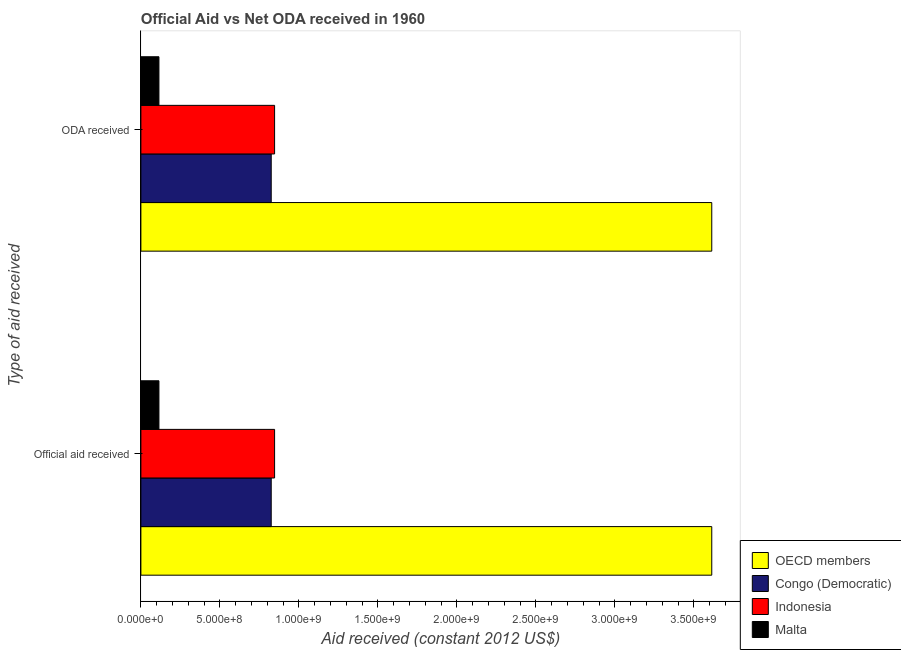How many different coloured bars are there?
Provide a short and direct response. 4. How many groups of bars are there?
Provide a short and direct response. 2. How many bars are there on the 2nd tick from the bottom?
Your answer should be compact. 4. What is the label of the 1st group of bars from the top?
Ensure brevity in your answer.  ODA received. What is the oda received in Congo (Democratic)?
Keep it short and to the point. 8.25e+08. Across all countries, what is the maximum oda received?
Your response must be concise. 3.61e+09. Across all countries, what is the minimum oda received?
Make the answer very short. 1.14e+08. In which country was the oda received maximum?
Offer a terse response. OECD members. In which country was the official aid received minimum?
Your answer should be very brief. Malta. What is the total oda received in the graph?
Offer a terse response. 5.40e+09. What is the difference between the oda received in OECD members and that in Malta?
Offer a terse response. 3.50e+09. What is the difference between the oda received in Congo (Democratic) and the official aid received in OECD members?
Provide a short and direct response. -2.79e+09. What is the average oda received per country?
Offer a very short reply. 1.35e+09. In how many countries, is the oda received greater than 2900000000 US$?
Offer a very short reply. 1. What is the ratio of the oda received in OECD members to that in Indonesia?
Ensure brevity in your answer.  4.27. What does the 2nd bar from the bottom in Official aid received represents?
Provide a succinct answer. Congo (Democratic). What is the difference between two consecutive major ticks on the X-axis?
Offer a very short reply. 5.00e+08. Are the values on the major ticks of X-axis written in scientific E-notation?
Provide a succinct answer. Yes. Does the graph contain any zero values?
Your response must be concise. No. Where does the legend appear in the graph?
Offer a very short reply. Bottom right. How many legend labels are there?
Your answer should be compact. 4. How are the legend labels stacked?
Keep it short and to the point. Vertical. What is the title of the graph?
Keep it short and to the point. Official Aid vs Net ODA received in 1960 . What is the label or title of the X-axis?
Ensure brevity in your answer.  Aid received (constant 2012 US$). What is the label or title of the Y-axis?
Ensure brevity in your answer.  Type of aid received. What is the Aid received (constant 2012 US$) of OECD members in Official aid received?
Give a very brief answer. 3.61e+09. What is the Aid received (constant 2012 US$) in Congo (Democratic) in Official aid received?
Make the answer very short. 8.25e+08. What is the Aid received (constant 2012 US$) of Indonesia in Official aid received?
Give a very brief answer. 8.46e+08. What is the Aid received (constant 2012 US$) in Malta in Official aid received?
Your answer should be very brief. 1.14e+08. What is the Aid received (constant 2012 US$) in OECD members in ODA received?
Keep it short and to the point. 3.61e+09. What is the Aid received (constant 2012 US$) of Congo (Democratic) in ODA received?
Make the answer very short. 8.25e+08. What is the Aid received (constant 2012 US$) in Indonesia in ODA received?
Ensure brevity in your answer.  8.46e+08. What is the Aid received (constant 2012 US$) of Malta in ODA received?
Your answer should be compact. 1.14e+08. Across all Type of aid received, what is the maximum Aid received (constant 2012 US$) of OECD members?
Give a very brief answer. 3.61e+09. Across all Type of aid received, what is the maximum Aid received (constant 2012 US$) of Congo (Democratic)?
Ensure brevity in your answer.  8.25e+08. Across all Type of aid received, what is the maximum Aid received (constant 2012 US$) in Indonesia?
Offer a very short reply. 8.46e+08. Across all Type of aid received, what is the maximum Aid received (constant 2012 US$) of Malta?
Provide a succinct answer. 1.14e+08. Across all Type of aid received, what is the minimum Aid received (constant 2012 US$) in OECD members?
Give a very brief answer. 3.61e+09. Across all Type of aid received, what is the minimum Aid received (constant 2012 US$) of Congo (Democratic)?
Provide a short and direct response. 8.25e+08. Across all Type of aid received, what is the minimum Aid received (constant 2012 US$) of Indonesia?
Your response must be concise. 8.46e+08. Across all Type of aid received, what is the minimum Aid received (constant 2012 US$) of Malta?
Offer a very short reply. 1.14e+08. What is the total Aid received (constant 2012 US$) of OECD members in the graph?
Ensure brevity in your answer.  7.23e+09. What is the total Aid received (constant 2012 US$) of Congo (Democratic) in the graph?
Provide a succinct answer. 1.65e+09. What is the total Aid received (constant 2012 US$) in Indonesia in the graph?
Offer a terse response. 1.69e+09. What is the total Aid received (constant 2012 US$) in Malta in the graph?
Ensure brevity in your answer.  2.29e+08. What is the difference between the Aid received (constant 2012 US$) in OECD members in Official aid received and that in ODA received?
Ensure brevity in your answer.  0. What is the difference between the Aid received (constant 2012 US$) in OECD members in Official aid received and the Aid received (constant 2012 US$) in Congo (Democratic) in ODA received?
Your response must be concise. 2.79e+09. What is the difference between the Aid received (constant 2012 US$) of OECD members in Official aid received and the Aid received (constant 2012 US$) of Indonesia in ODA received?
Keep it short and to the point. 2.77e+09. What is the difference between the Aid received (constant 2012 US$) in OECD members in Official aid received and the Aid received (constant 2012 US$) in Malta in ODA received?
Keep it short and to the point. 3.50e+09. What is the difference between the Aid received (constant 2012 US$) in Congo (Democratic) in Official aid received and the Aid received (constant 2012 US$) in Indonesia in ODA received?
Give a very brief answer. -2.13e+07. What is the difference between the Aid received (constant 2012 US$) of Congo (Democratic) in Official aid received and the Aid received (constant 2012 US$) of Malta in ODA received?
Your answer should be very brief. 7.11e+08. What is the difference between the Aid received (constant 2012 US$) in Indonesia in Official aid received and the Aid received (constant 2012 US$) in Malta in ODA received?
Your answer should be compact. 7.32e+08. What is the average Aid received (constant 2012 US$) in OECD members per Type of aid received?
Provide a short and direct response. 3.61e+09. What is the average Aid received (constant 2012 US$) of Congo (Democratic) per Type of aid received?
Offer a terse response. 8.25e+08. What is the average Aid received (constant 2012 US$) of Indonesia per Type of aid received?
Provide a succinct answer. 8.46e+08. What is the average Aid received (constant 2012 US$) in Malta per Type of aid received?
Keep it short and to the point. 1.14e+08. What is the difference between the Aid received (constant 2012 US$) in OECD members and Aid received (constant 2012 US$) in Congo (Democratic) in Official aid received?
Your answer should be very brief. 2.79e+09. What is the difference between the Aid received (constant 2012 US$) of OECD members and Aid received (constant 2012 US$) of Indonesia in Official aid received?
Make the answer very short. 2.77e+09. What is the difference between the Aid received (constant 2012 US$) of OECD members and Aid received (constant 2012 US$) of Malta in Official aid received?
Provide a short and direct response. 3.50e+09. What is the difference between the Aid received (constant 2012 US$) in Congo (Democratic) and Aid received (constant 2012 US$) in Indonesia in Official aid received?
Ensure brevity in your answer.  -2.13e+07. What is the difference between the Aid received (constant 2012 US$) in Congo (Democratic) and Aid received (constant 2012 US$) in Malta in Official aid received?
Give a very brief answer. 7.11e+08. What is the difference between the Aid received (constant 2012 US$) of Indonesia and Aid received (constant 2012 US$) of Malta in Official aid received?
Your answer should be very brief. 7.32e+08. What is the difference between the Aid received (constant 2012 US$) of OECD members and Aid received (constant 2012 US$) of Congo (Democratic) in ODA received?
Give a very brief answer. 2.79e+09. What is the difference between the Aid received (constant 2012 US$) in OECD members and Aid received (constant 2012 US$) in Indonesia in ODA received?
Provide a short and direct response. 2.77e+09. What is the difference between the Aid received (constant 2012 US$) in OECD members and Aid received (constant 2012 US$) in Malta in ODA received?
Make the answer very short. 3.50e+09. What is the difference between the Aid received (constant 2012 US$) of Congo (Democratic) and Aid received (constant 2012 US$) of Indonesia in ODA received?
Your answer should be compact. -2.13e+07. What is the difference between the Aid received (constant 2012 US$) in Congo (Democratic) and Aid received (constant 2012 US$) in Malta in ODA received?
Your response must be concise. 7.11e+08. What is the difference between the Aid received (constant 2012 US$) of Indonesia and Aid received (constant 2012 US$) of Malta in ODA received?
Provide a short and direct response. 7.32e+08. What is the ratio of the Aid received (constant 2012 US$) in Congo (Democratic) in Official aid received to that in ODA received?
Provide a short and direct response. 1. What is the ratio of the Aid received (constant 2012 US$) of Malta in Official aid received to that in ODA received?
Keep it short and to the point. 1. What is the difference between the highest and the second highest Aid received (constant 2012 US$) of Indonesia?
Provide a succinct answer. 0. What is the difference between the highest and the lowest Aid received (constant 2012 US$) in OECD members?
Give a very brief answer. 0. What is the difference between the highest and the lowest Aid received (constant 2012 US$) of Malta?
Offer a very short reply. 0. 